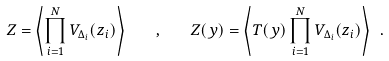<formula> <loc_0><loc_0><loc_500><loc_500>Z = \left < \prod _ { i = 1 } ^ { N } V _ { \Delta _ { i } } ( z _ { i } ) \right > \quad , \quad Z ( y ) = \left < T ( y ) \prod _ { i = 1 } ^ { N } V _ { \Delta _ { i } } ( z _ { i } ) \right > \ .</formula> 